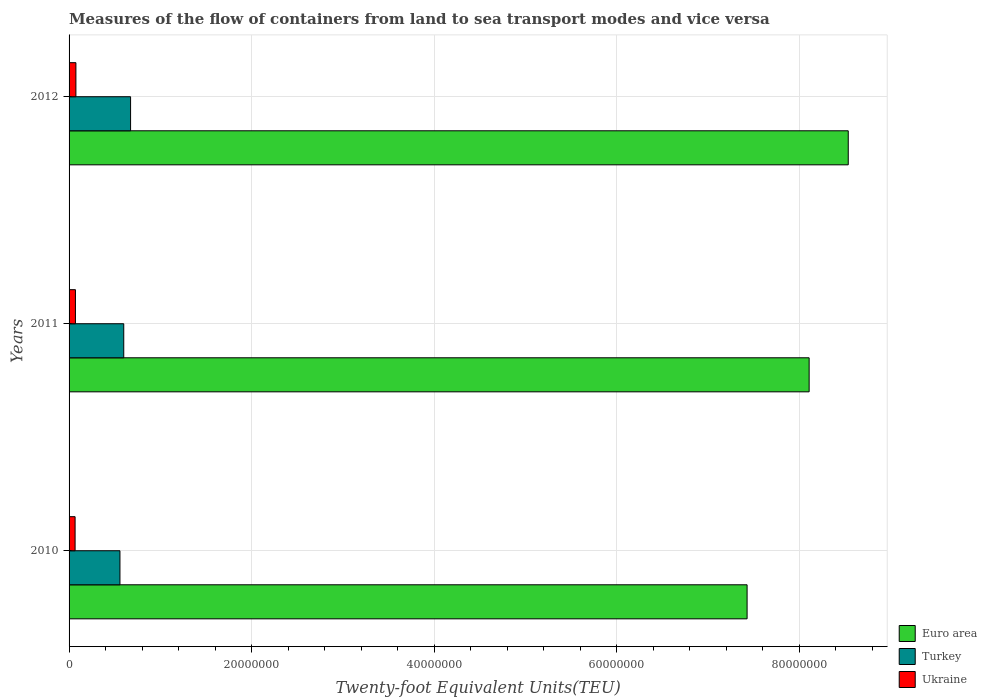How many different coloured bars are there?
Make the answer very short. 3. How many groups of bars are there?
Your answer should be compact. 3. Are the number of bars per tick equal to the number of legend labels?
Offer a very short reply. Yes. Are the number of bars on each tick of the Y-axis equal?
Make the answer very short. Yes. How many bars are there on the 3rd tick from the top?
Ensure brevity in your answer.  3. What is the label of the 3rd group of bars from the top?
Ensure brevity in your answer.  2010. In how many cases, is the number of bars for a given year not equal to the number of legend labels?
Make the answer very short. 0. What is the container port traffic in Turkey in 2011?
Keep it short and to the point. 5.99e+06. Across all years, what is the maximum container port traffic in Ukraine?
Your answer should be compact. 7.49e+05. Across all years, what is the minimum container port traffic in Euro area?
Your answer should be compact. 7.43e+07. In which year was the container port traffic in Euro area minimum?
Offer a very short reply. 2010. What is the total container port traffic in Turkey in the graph?
Your answer should be very brief. 1.83e+07. What is the difference between the container port traffic in Turkey in 2011 and that in 2012?
Make the answer very short. -7.46e+05. What is the difference between the container port traffic in Turkey in 2010 and the container port traffic in Euro area in 2011?
Make the answer very short. -7.55e+07. What is the average container port traffic in Turkey per year?
Your answer should be very brief. 6.10e+06. In the year 2012, what is the difference between the container port traffic in Ukraine and container port traffic in Turkey?
Provide a succinct answer. -5.99e+06. What is the ratio of the container port traffic in Turkey in 2011 to that in 2012?
Offer a very short reply. 0.89. Is the container port traffic in Turkey in 2011 less than that in 2012?
Your response must be concise. Yes. What is the difference between the highest and the second highest container port traffic in Turkey?
Your answer should be compact. 7.46e+05. What is the difference between the highest and the lowest container port traffic in Euro area?
Provide a short and direct response. 1.11e+07. Is it the case that in every year, the sum of the container port traffic in Turkey and container port traffic in Ukraine is greater than the container port traffic in Euro area?
Your response must be concise. No. How many bars are there?
Keep it short and to the point. 9. Are all the bars in the graph horizontal?
Your response must be concise. Yes. What is the difference between two consecutive major ticks on the X-axis?
Give a very brief answer. 2.00e+07. Are the values on the major ticks of X-axis written in scientific E-notation?
Ensure brevity in your answer.  No. Does the graph contain any zero values?
Offer a very short reply. No. How many legend labels are there?
Your answer should be very brief. 3. How are the legend labels stacked?
Provide a succinct answer. Vertical. What is the title of the graph?
Ensure brevity in your answer.  Measures of the flow of containers from land to sea transport modes and vice versa. What is the label or title of the X-axis?
Your answer should be very brief. Twenty-foot Equivalent Units(TEU). What is the Twenty-foot Equivalent Units(TEU) in Euro area in 2010?
Keep it short and to the point. 7.43e+07. What is the Twenty-foot Equivalent Units(TEU) of Turkey in 2010?
Keep it short and to the point. 5.57e+06. What is the Twenty-foot Equivalent Units(TEU) in Ukraine in 2010?
Your answer should be very brief. 6.60e+05. What is the Twenty-foot Equivalent Units(TEU) of Euro area in 2011?
Your answer should be compact. 8.11e+07. What is the Twenty-foot Equivalent Units(TEU) of Turkey in 2011?
Make the answer very short. 5.99e+06. What is the Twenty-foot Equivalent Units(TEU) of Ukraine in 2011?
Provide a succinct answer. 6.97e+05. What is the Twenty-foot Equivalent Units(TEU) of Euro area in 2012?
Your answer should be compact. 8.53e+07. What is the Twenty-foot Equivalent Units(TEU) in Turkey in 2012?
Offer a very short reply. 6.74e+06. What is the Twenty-foot Equivalent Units(TEU) in Ukraine in 2012?
Ensure brevity in your answer.  7.49e+05. Across all years, what is the maximum Twenty-foot Equivalent Units(TEU) in Euro area?
Give a very brief answer. 8.53e+07. Across all years, what is the maximum Twenty-foot Equivalent Units(TEU) in Turkey?
Provide a succinct answer. 6.74e+06. Across all years, what is the maximum Twenty-foot Equivalent Units(TEU) of Ukraine?
Make the answer very short. 7.49e+05. Across all years, what is the minimum Twenty-foot Equivalent Units(TEU) of Euro area?
Your response must be concise. 7.43e+07. Across all years, what is the minimum Twenty-foot Equivalent Units(TEU) of Turkey?
Your response must be concise. 5.57e+06. Across all years, what is the minimum Twenty-foot Equivalent Units(TEU) of Ukraine?
Offer a very short reply. 6.60e+05. What is the total Twenty-foot Equivalent Units(TEU) in Euro area in the graph?
Provide a succinct answer. 2.41e+08. What is the total Twenty-foot Equivalent Units(TEU) of Turkey in the graph?
Provide a succinct answer. 1.83e+07. What is the total Twenty-foot Equivalent Units(TEU) in Ukraine in the graph?
Ensure brevity in your answer.  2.11e+06. What is the difference between the Twenty-foot Equivalent Units(TEU) in Euro area in 2010 and that in 2011?
Make the answer very short. -6.80e+06. What is the difference between the Twenty-foot Equivalent Units(TEU) in Turkey in 2010 and that in 2011?
Provide a short and direct response. -4.16e+05. What is the difference between the Twenty-foot Equivalent Units(TEU) in Ukraine in 2010 and that in 2011?
Provide a succinct answer. -3.71e+04. What is the difference between the Twenty-foot Equivalent Units(TEU) in Euro area in 2010 and that in 2012?
Keep it short and to the point. -1.11e+07. What is the difference between the Twenty-foot Equivalent Units(TEU) in Turkey in 2010 and that in 2012?
Make the answer very short. -1.16e+06. What is the difference between the Twenty-foot Equivalent Units(TEU) of Ukraine in 2010 and that in 2012?
Make the answer very short. -8.93e+04. What is the difference between the Twenty-foot Equivalent Units(TEU) of Euro area in 2011 and that in 2012?
Offer a terse response. -4.28e+06. What is the difference between the Twenty-foot Equivalent Units(TEU) of Turkey in 2011 and that in 2012?
Make the answer very short. -7.46e+05. What is the difference between the Twenty-foot Equivalent Units(TEU) in Ukraine in 2011 and that in 2012?
Make the answer very short. -5.22e+04. What is the difference between the Twenty-foot Equivalent Units(TEU) of Euro area in 2010 and the Twenty-foot Equivalent Units(TEU) of Turkey in 2011?
Your answer should be very brief. 6.83e+07. What is the difference between the Twenty-foot Equivalent Units(TEU) of Euro area in 2010 and the Twenty-foot Equivalent Units(TEU) of Ukraine in 2011?
Offer a terse response. 7.36e+07. What is the difference between the Twenty-foot Equivalent Units(TEU) in Turkey in 2010 and the Twenty-foot Equivalent Units(TEU) in Ukraine in 2011?
Provide a succinct answer. 4.88e+06. What is the difference between the Twenty-foot Equivalent Units(TEU) of Euro area in 2010 and the Twenty-foot Equivalent Units(TEU) of Turkey in 2012?
Give a very brief answer. 6.75e+07. What is the difference between the Twenty-foot Equivalent Units(TEU) in Euro area in 2010 and the Twenty-foot Equivalent Units(TEU) in Ukraine in 2012?
Your response must be concise. 7.35e+07. What is the difference between the Twenty-foot Equivalent Units(TEU) of Turkey in 2010 and the Twenty-foot Equivalent Units(TEU) of Ukraine in 2012?
Offer a very short reply. 4.83e+06. What is the difference between the Twenty-foot Equivalent Units(TEU) of Euro area in 2011 and the Twenty-foot Equivalent Units(TEU) of Turkey in 2012?
Offer a terse response. 7.43e+07. What is the difference between the Twenty-foot Equivalent Units(TEU) of Euro area in 2011 and the Twenty-foot Equivalent Units(TEU) of Ukraine in 2012?
Your response must be concise. 8.03e+07. What is the difference between the Twenty-foot Equivalent Units(TEU) of Turkey in 2011 and the Twenty-foot Equivalent Units(TEU) of Ukraine in 2012?
Provide a succinct answer. 5.24e+06. What is the average Twenty-foot Equivalent Units(TEU) of Euro area per year?
Provide a succinct answer. 8.02e+07. What is the average Twenty-foot Equivalent Units(TEU) in Turkey per year?
Make the answer very short. 6.10e+06. What is the average Twenty-foot Equivalent Units(TEU) of Ukraine per year?
Your answer should be compact. 7.02e+05. In the year 2010, what is the difference between the Twenty-foot Equivalent Units(TEU) in Euro area and Twenty-foot Equivalent Units(TEU) in Turkey?
Offer a very short reply. 6.87e+07. In the year 2010, what is the difference between the Twenty-foot Equivalent Units(TEU) in Euro area and Twenty-foot Equivalent Units(TEU) in Ukraine?
Your answer should be compact. 7.36e+07. In the year 2010, what is the difference between the Twenty-foot Equivalent Units(TEU) in Turkey and Twenty-foot Equivalent Units(TEU) in Ukraine?
Keep it short and to the point. 4.91e+06. In the year 2011, what is the difference between the Twenty-foot Equivalent Units(TEU) of Euro area and Twenty-foot Equivalent Units(TEU) of Turkey?
Your answer should be very brief. 7.51e+07. In the year 2011, what is the difference between the Twenty-foot Equivalent Units(TEU) in Euro area and Twenty-foot Equivalent Units(TEU) in Ukraine?
Offer a terse response. 8.04e+07. In the year 2011, what is the difference between the Twenty-foot Equivalent Units(TEU) of Turkey and Twenty-foot Equivalent Units(TEU) of Ukraine?
Offer a very short reply. 5.29e+06. In the year 2012, what is the difference between the Twenty-foot Equivalent Units(TEU) in Euro area and Twenty-foot Equivalent Units(TEU) in Turkey?
Offer a terse response. 7.86e+07. In the year 2012, what is the difference between the Twenty-foot Equivalent Units(TEU) in Euro area and Twenty-foot Equivalent Units(TEU) in Ukraine?
Your answer should be very brief. 8.46e+07. In the year 2012, what is the difference between the Twenty-foot Equivalent Units(TEU) in Turkey and Twenty-foot Equivalent Units(TEU) in Ukraine?
Your answer should be very brief. 5.99e+06. What is the ratio of the Twenty-foot Equivalent Units(TEU) in Euro area in 2010 to that in 2011?
Provide a short and direct response. 0.92. What is the ratio of the Twenty-foot Equivalent Units(TEU) in Turkey in 2010 to that in 2011?
Make the answer very short. 0.93. What is the ratio of the Twenty-foot Equivalent Units(TEU) in Ukraine in 2010 to that in 2011?
Ensure brevity in your answer.  0.95. What is the ratio of the Twenty-foot Equivalent Units(TEU) of Euro area in 2010 to that in 2012?
Give a very brief answer. 0.87. What is the ratio of the Twenty-foot Equivalent Units(TEU) of Turkey in 2010 to that in 2012?
Ensure brevity in your answer.  0.83. What is the ratio of the Twenty-foot Equivalent Units(TEU) in Ukraine in 2010 to that in 2012?
Keep it short and to the point. 0.88. What is the ratio of the Twenty-foot Equivalent Units(TEU) of Euro area in 2011 to that in 2012?
Your answer should be compact. 0.95. What is the ratio of the Twenty-foot Equivalent Units(TEU) in Turkey in 2011 to that in 2012?
Offer a terse response. 0.89. What is the ratio of the Twenty-foot Equivalent Units(TEU) in Ukraine in 2011 to that in 2012?
Offer a terse response. 0.93. What is the difference between the highest and the second highest Twenty-foot Equivalent Units(TEU) in Euro area?
Give a very brief answer. 4.28e+06. What is the difference between the highest and the second highest Twenty-foot Equivalent Units(TEU) in Turkey?
Offer a very short reply. 7.46e+05. What is the difference between the highest and the second highest Twenty-foot Equivalent Units(TEU) in Ukraine?
Give a very brief answer. 5.22e+04. What is the difference between the highest and the lowest Twenty-foot Equivalent Units(TEU) in Euro area?
Your answer should be very brief. 1.11e+07. What is the difference between the highest and the lowest Twenty-foot Equivalent Units(TEU) in Turkey?
Provide a succinct answer. 1.16e+06. What is the difference between the highest and the lowest Twenty-foot Equivalent Units(TEU) in Ukraine?
Offer a terse response. 8.93e+04. 